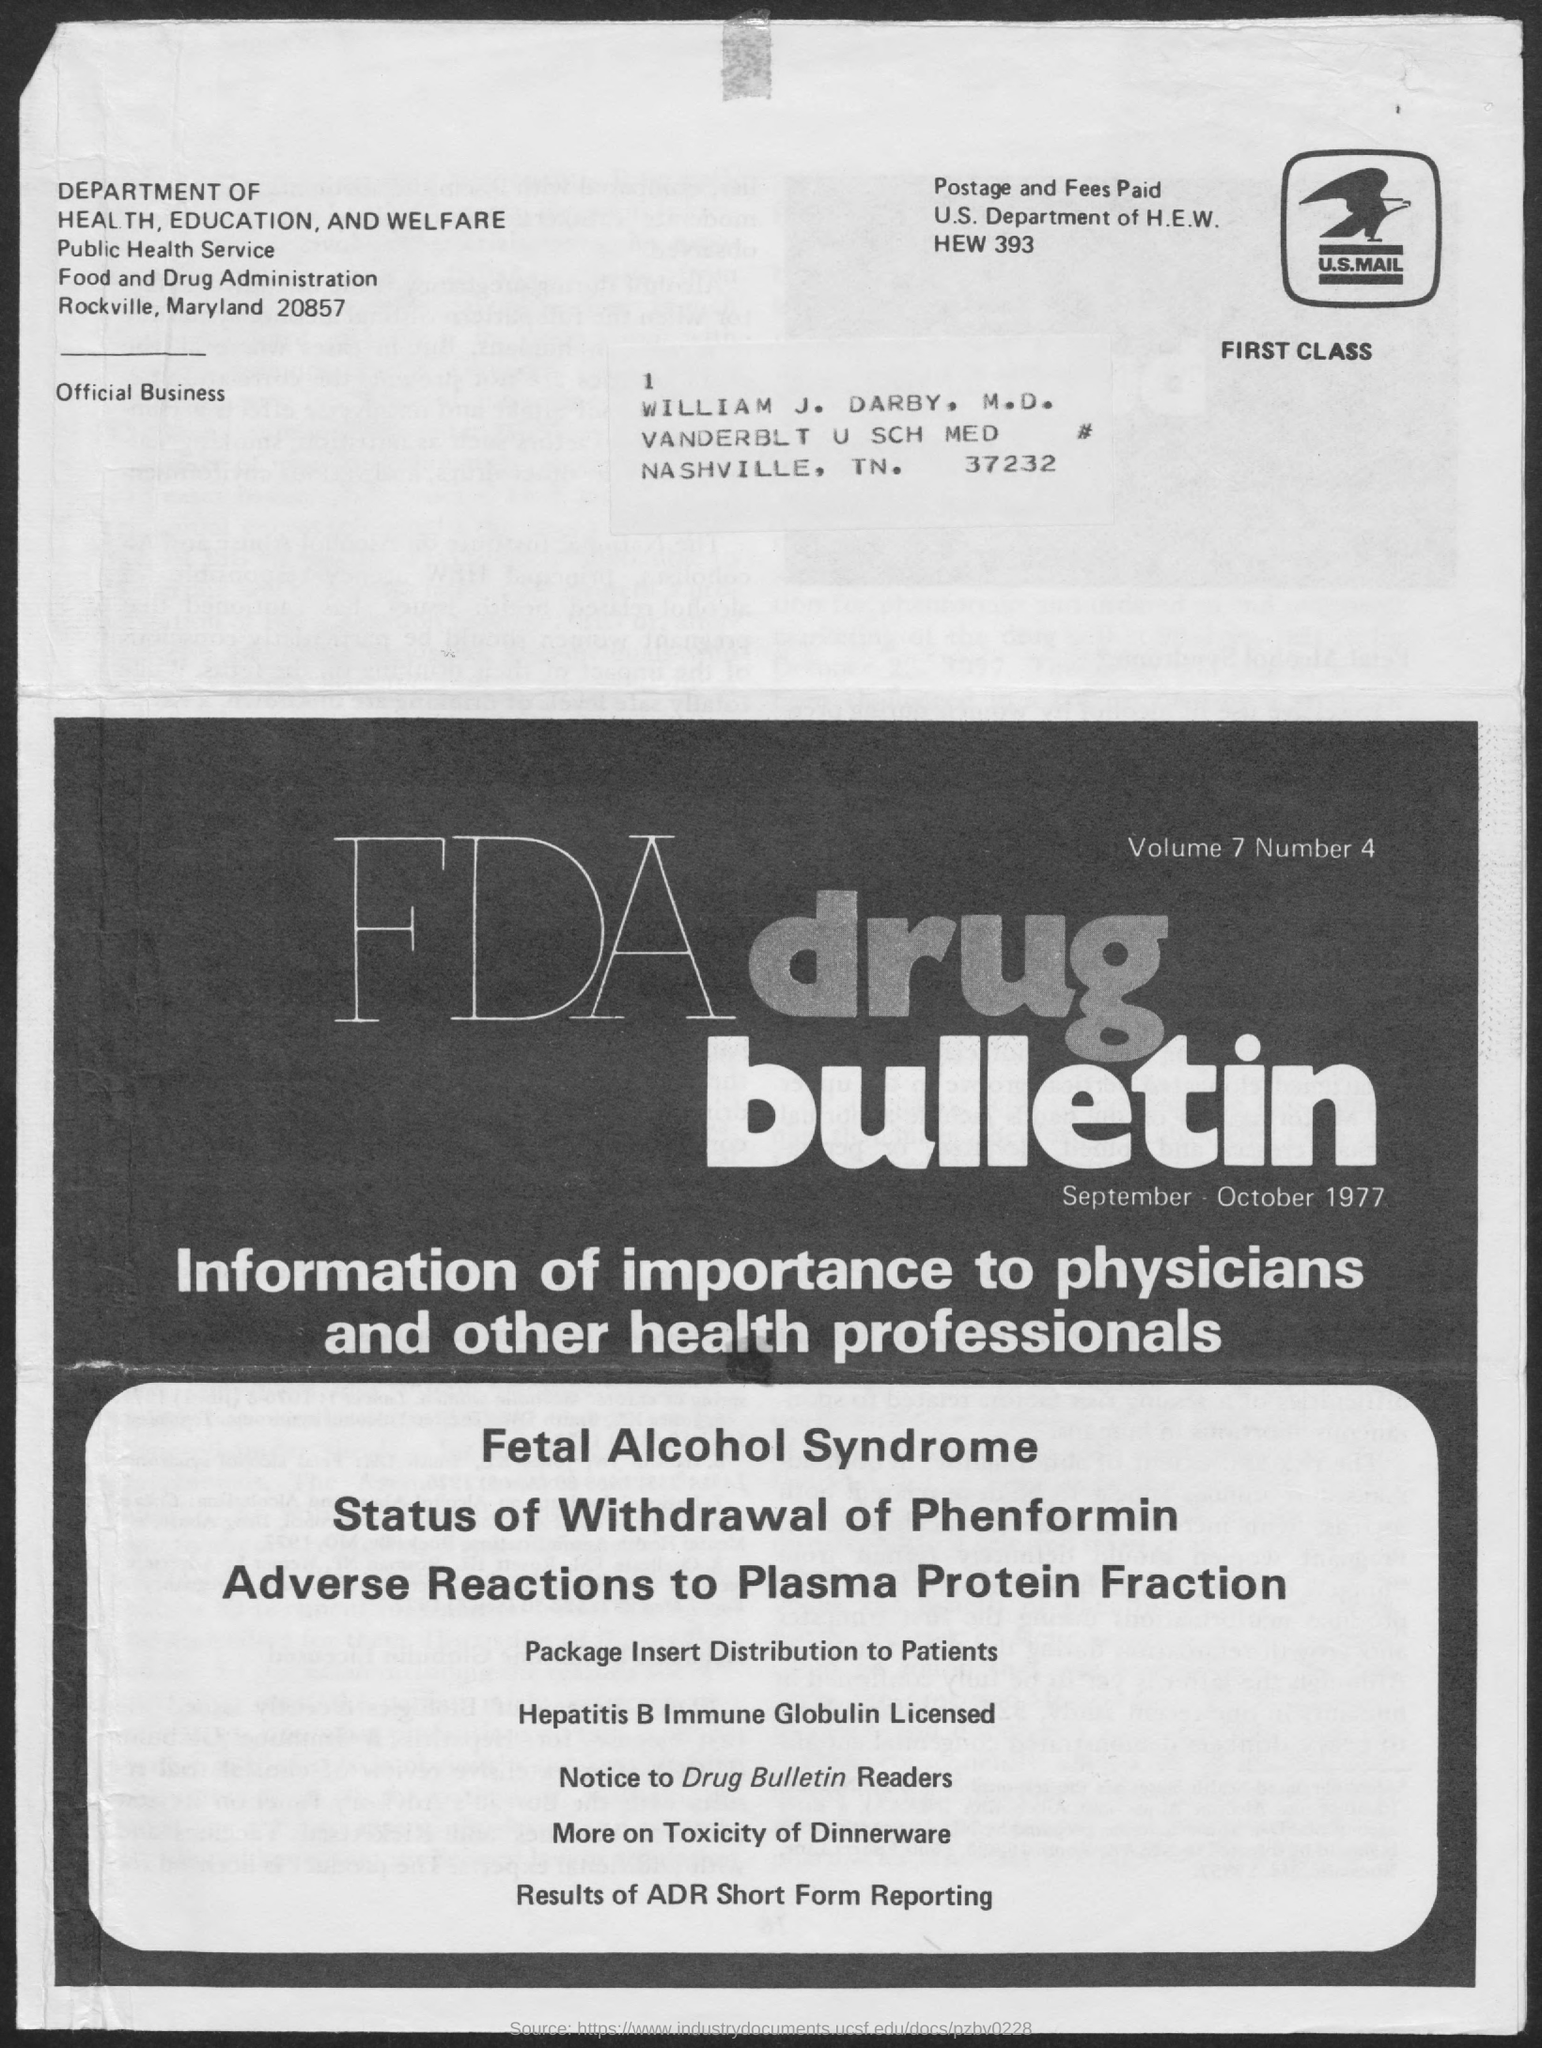Mention a couple of crucial points in this snapshot. What is the number, specifically 4 with a dot after it? This is the September-October 1977 bulletin. What is the volume? 7.." is a question asking for information about the volume of an object or a quantity. The letter is addressed to William J. Darby. 